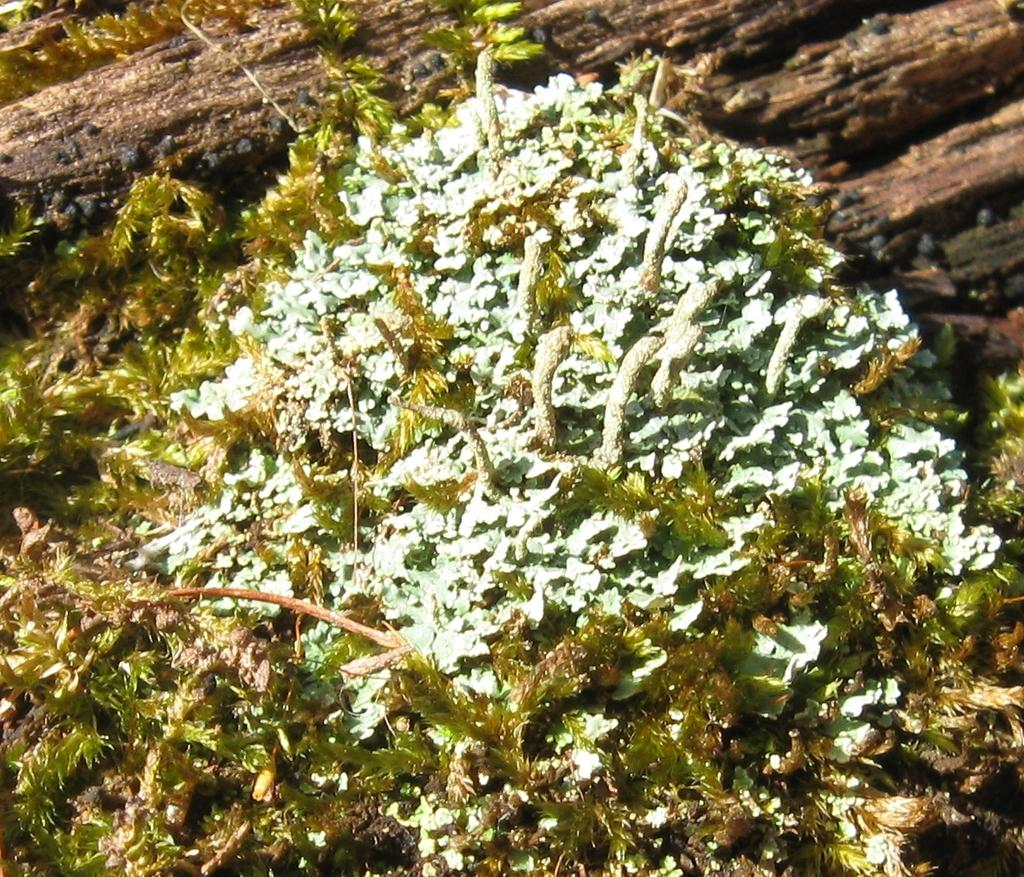What type of organism can be seen on the stone in the image? There is algae on a stone in the image. How many trucks are visible in the image? There are no trucks present in the image; it features algae on a stone. What type of reptile can be seen slithering on the stone in the image? There are no reptiles, specifically snakes, present in the image; it features algae on a stone. 